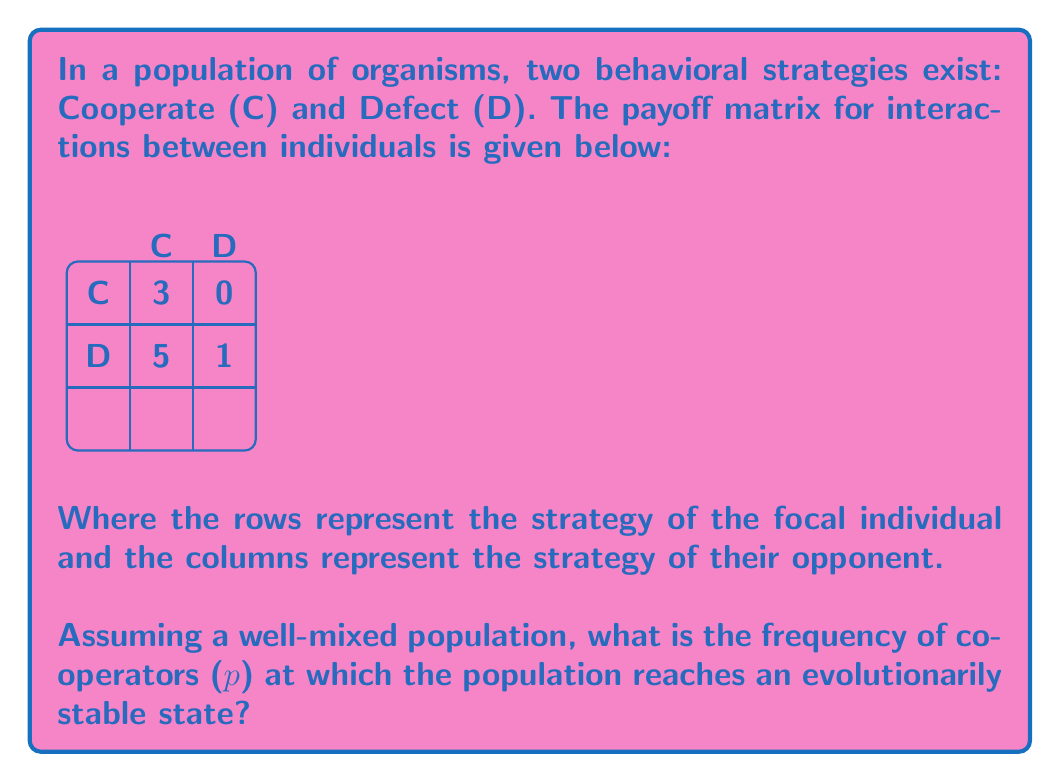Can you answer this question? To find the evolutionarily stable state, we need to determine when the fitness of cooperators equals the fitness of defectors. Let's approach this step-by-step:

1) Let $p$ be the frequency of cooperators in the population. Then, the frequency of defectors is $(1-p)$.

2) The expected fitness of a cooperator ($W_C$) is:
   $W_C = 3p + 0(1-p) = 3p$

3) The expected fitness of a defector ($W_D$) is:
   $W_D = 5p + 1(1-p) = 5p + 1 - p = 4p + 1$

4) At the evolutionarily stable state, these fitnesses should be equal:
   $W_C = W_D$
   $3p = 4p + 1$

5) Solving this equation:
   $3p = 4p + 1$
   $-p = 1$
   $p = -1$

6) However, since $p$ represents a frequency, it must be between 0 and 1. The negative solution indicates that there is no internal equilibrium where both strategies coexist.

7) To determine the evolutionarily stable state, we need to compare the fitnesses at the boundary conditions:

   At $p = 0$ (all defectors): 
   $W_C = 0$, $W_D = 1$
   Defectors have higher fitness.

   At $p = 1$ (all cooperators):
   $W_C = 3$, $W_D = 5$
   Defectors still have higher fitness.

8) This means that defection is the only evolutionarily stable strategy in this population. The population will evolve towards all defectors ($p = 0$).
Answer: $p = 0$ (all defectors) 